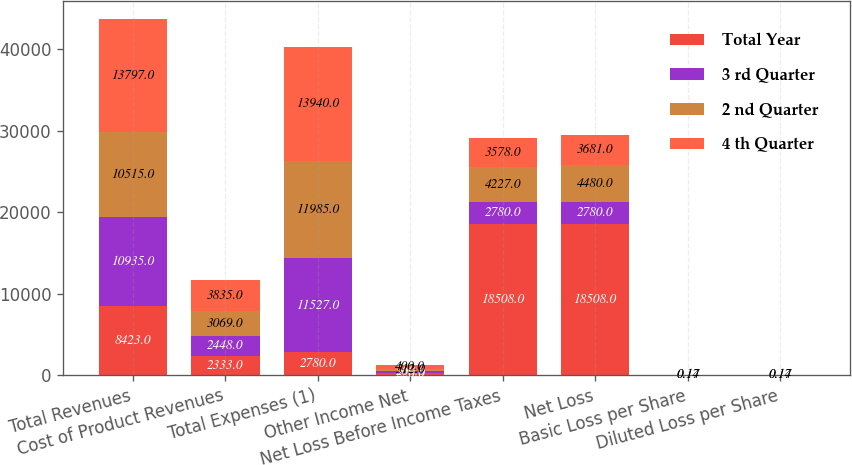<chart> <loc_0><loc_0><loc_500><loc_500><stacked_bar_chart><ecel><fcel>Total Revenues<fcel>Cost of Product Revenues<fcel>Total Expenses (1)<fcel>Other Income Net<fcel>Net Loss Before Income Taxes<fcel>Net Loss<fcel>Basic Loss per Share<fcel>Diluted Loss per Share<nl><fcel>Total Year<fcel>8423<fcel>2333<fcel>2780<fcel>226<fcel>18508<fcel>18508<fcel>0.77<fcel>0.77<nl><fcel>3 rd Quarter<fcel>10935<fcel>2448<fcel>11527<fcel>260<fcel>2780<fcel>2780<fcel>0.11<fcel>0.11<nl><fcel>2 nd Quarter<fcel>10515<fcel>3069<fcel>11985<fcel>312<fcel>4227<fcel>4480<fcel>0.17<fcel>0.17<nl><fcel>4 th Quarter<fcel>13797<fcel>3835<fcel>13940<fcel>400<fcel>3578<fcel>3681<fcel>0.14<fcel>0.14<nl></chart> 